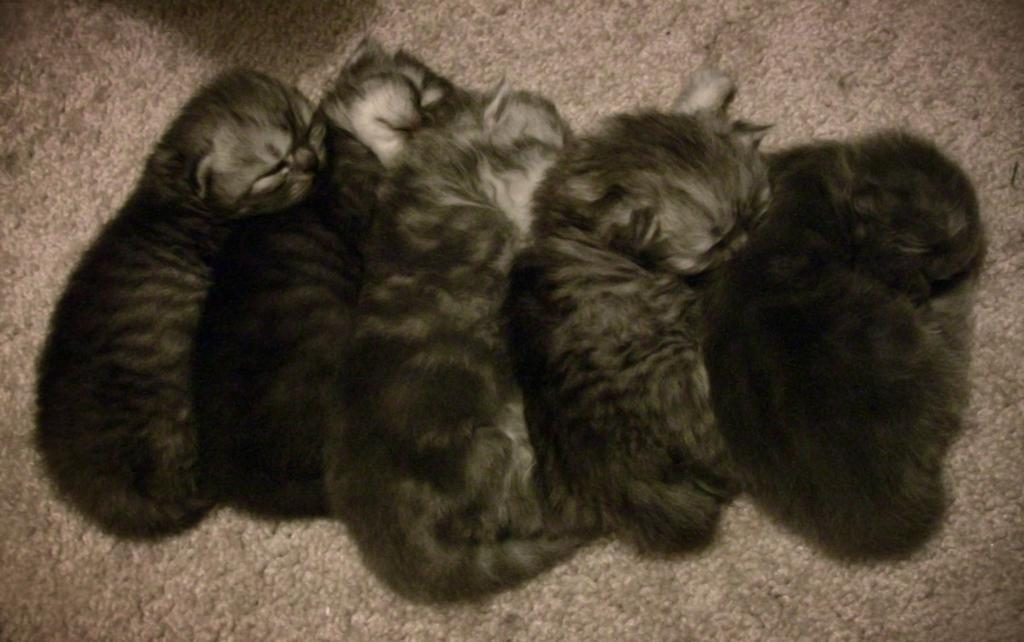What type of animals are in the picture? There are kittens in the picture. What is on the floor in the picture? There is a carpet on the floor in the picture. Reasoning: Let'g: Let's think step by step in order to produce the conversation. We start by identifying the main subject of the image, which is the kittens. Then, we describe the flooring in the image, which is a carpet. Each question is designed to elicit a specific detail about the image that is known from the provided facts. Absurd Question/Answer: What type of coal can be seen in the picture? There is no coal present in the picture; it features kittens and a carpet. What is the texture of the sail in the picture? There is no sail present in the picture; it only contains kittens and a carpet. What type of coal can be seen in the picture? There is no coal present in the picture; it features kittens and a carpet. What is the texture of the sail in the picture? There is no sail present in the picture; it only contains kittens and a carpet. 